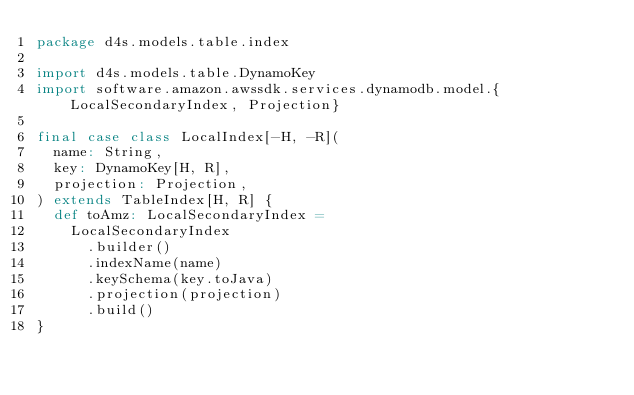<code> <loc_0><loc_0><loc_500><loc_500><_Scala_>package d4s.models.table.index

import d4s.models.table.DynamoKey
import software.amazon.awssdk.services.dynamodb.model.{LocalSecondaryIndex, Projection}

final case class LocalIndex[-H, -R](
  name: String,
  key: DynamoKey[H, R],
  projection: Projection,
) extends TableIndex[H, R] {
  def toAmz: LocalSecondaryIndex =
    LocalSecondaryIndex
      .builder()
      .indexName(name)
      .keySchema(key.toJava)
      .projection(projection)
      .build()
}
</code> 